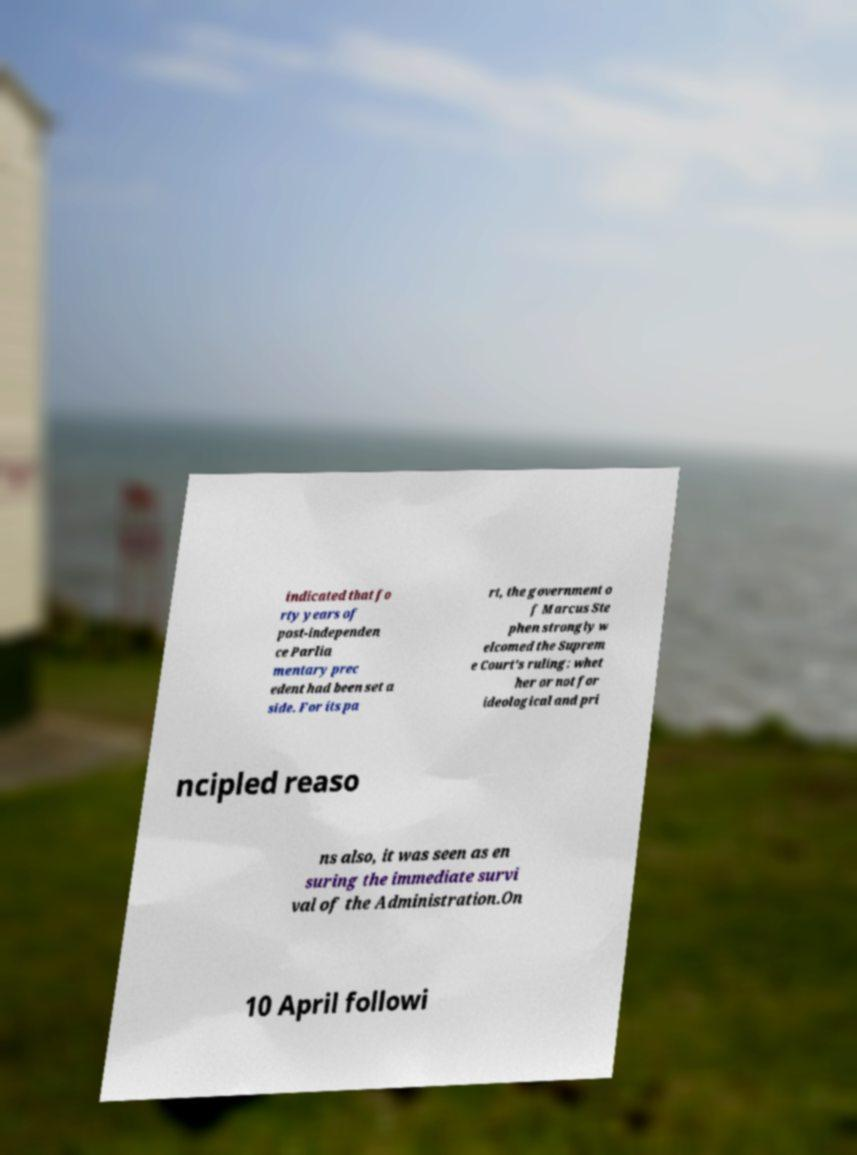There's text embedded in this image that I need extracted. Can you transcribe it verbatim? indicated that fo rty years of post-independen ce Parlia mentary prec edent had been set a side. For its pa rt, the government o f Marcus Ste phen strongly w elcomed the Suprem e Court's ruling: whet her or not for ideological and pri ncipled reaso ns also, it was seen as en suring the immediate survi val of the Administration.On 10 April followi 